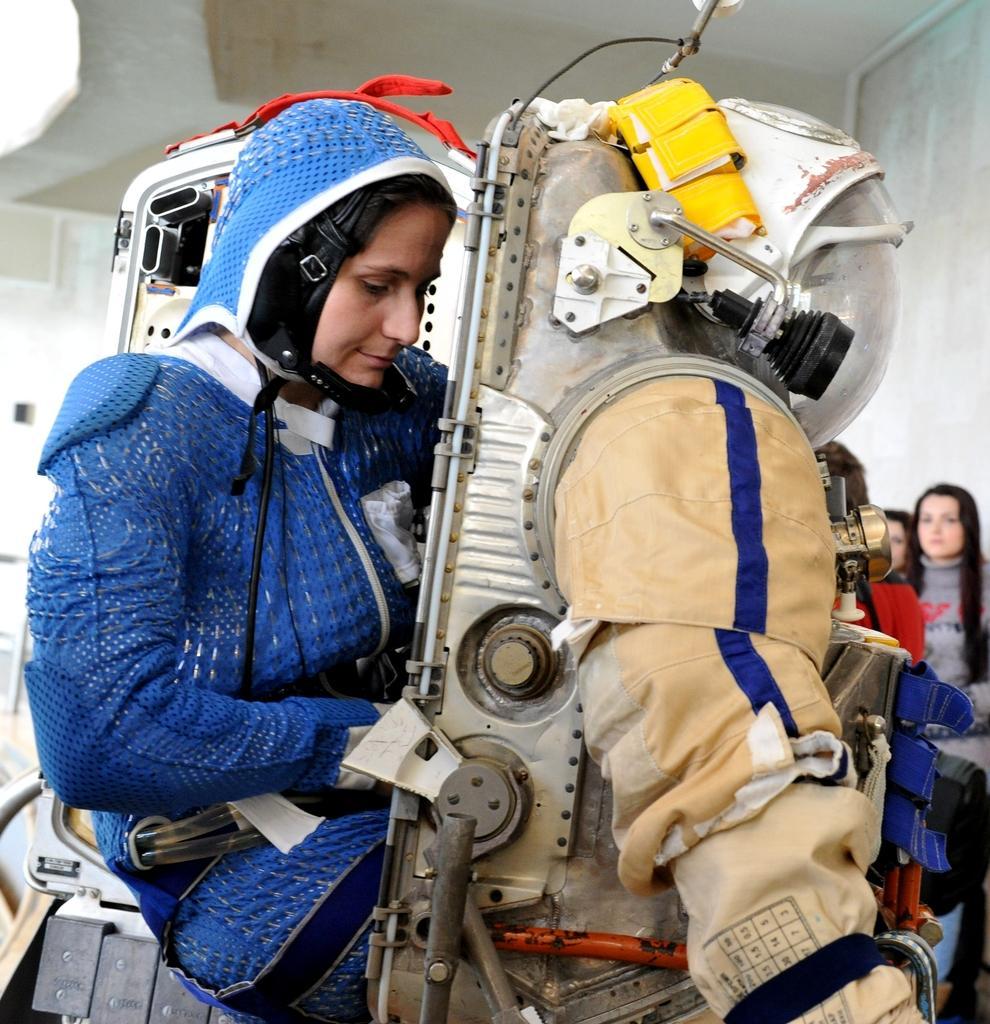In one or two sentences, can you explain what this image depicts? In the picture we can see a woman wearing and blue color costume and going to wear a space person dress and behind we can see some women are looking at her and in the background we can see a wall. 